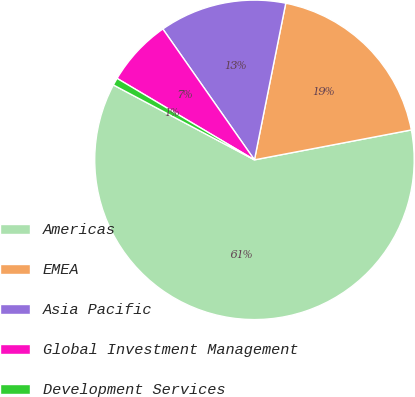<chart> <loc_0><loc_0><loc_500><loc_500><pie_chart><fcel>Americas<fcel>EMEA<fcel>Asia Pacific<fcel>Global Investment Management<fcel>Development Services<nl><fcel>60.76%<fcel>18.86%<fcel>12.86%<fcel>6.76%<fcel>0.75%<nl></chart> 